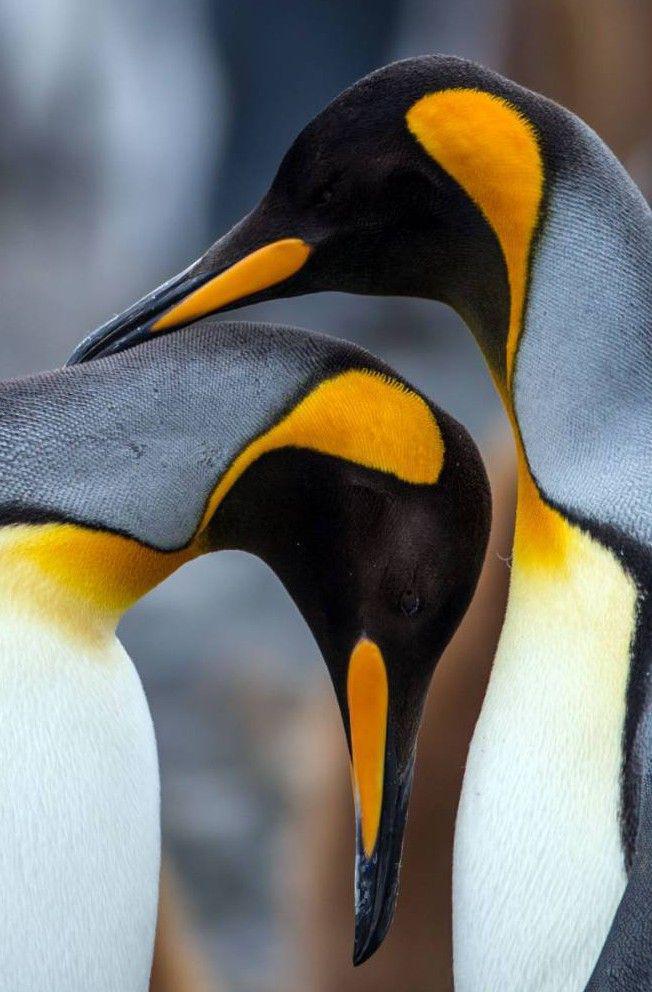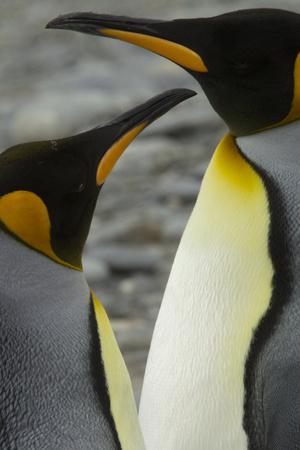The first image is the image on the left, the second image is the image on the right. Analyze the images presented: Is the assertion "Each of the images in the pair show exactly two penguins." valid? Answer yes or no. Yes. The first image is the image on the left, the second image is the image on the right. Examine the images to the left and right. Is the description "There is a total of 1 penguin grooming themselves." accurate? Answer yes or no. No. 